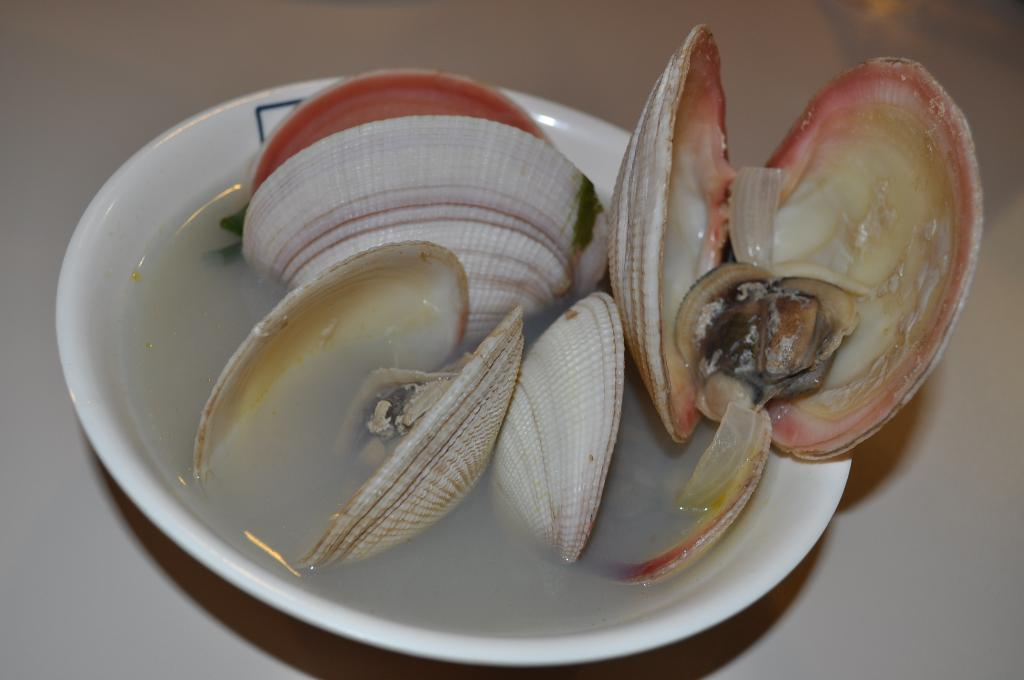What is located in the center of the image? There is a table in the center of the image. What is on top of the table? There is a bowl on the table. What is inside the bowl? The bowl contains water. What else can be found in the bowl? There are shells in the bowl. Can you see a tiger playing with the shells in the bowl? No, there is no tiger present in the image. 